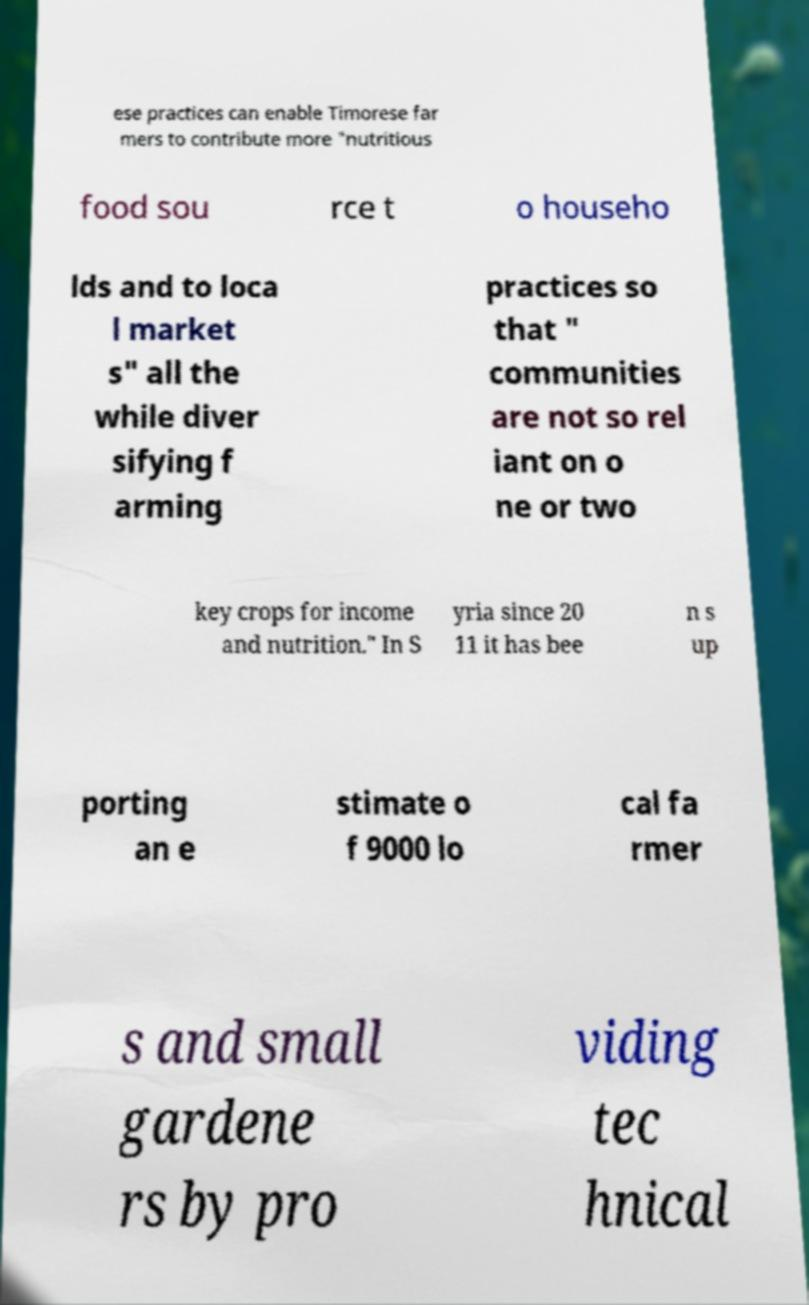Can you accurately transcribe the text from the provided image for me? ese practices can enable Timorese far mers to contribute more "nutritious food sou rce t o househo lds and to loca l market s" all the while diver sifying f arming practices so that " communities are not so rel iant on o ne or two key crops for income and nutrition." In S yria since 20 11 it has bee n s up porting an e stimate o f 9000 lo cal fa rmer s and small gardene rs by pro viding tec hnical 